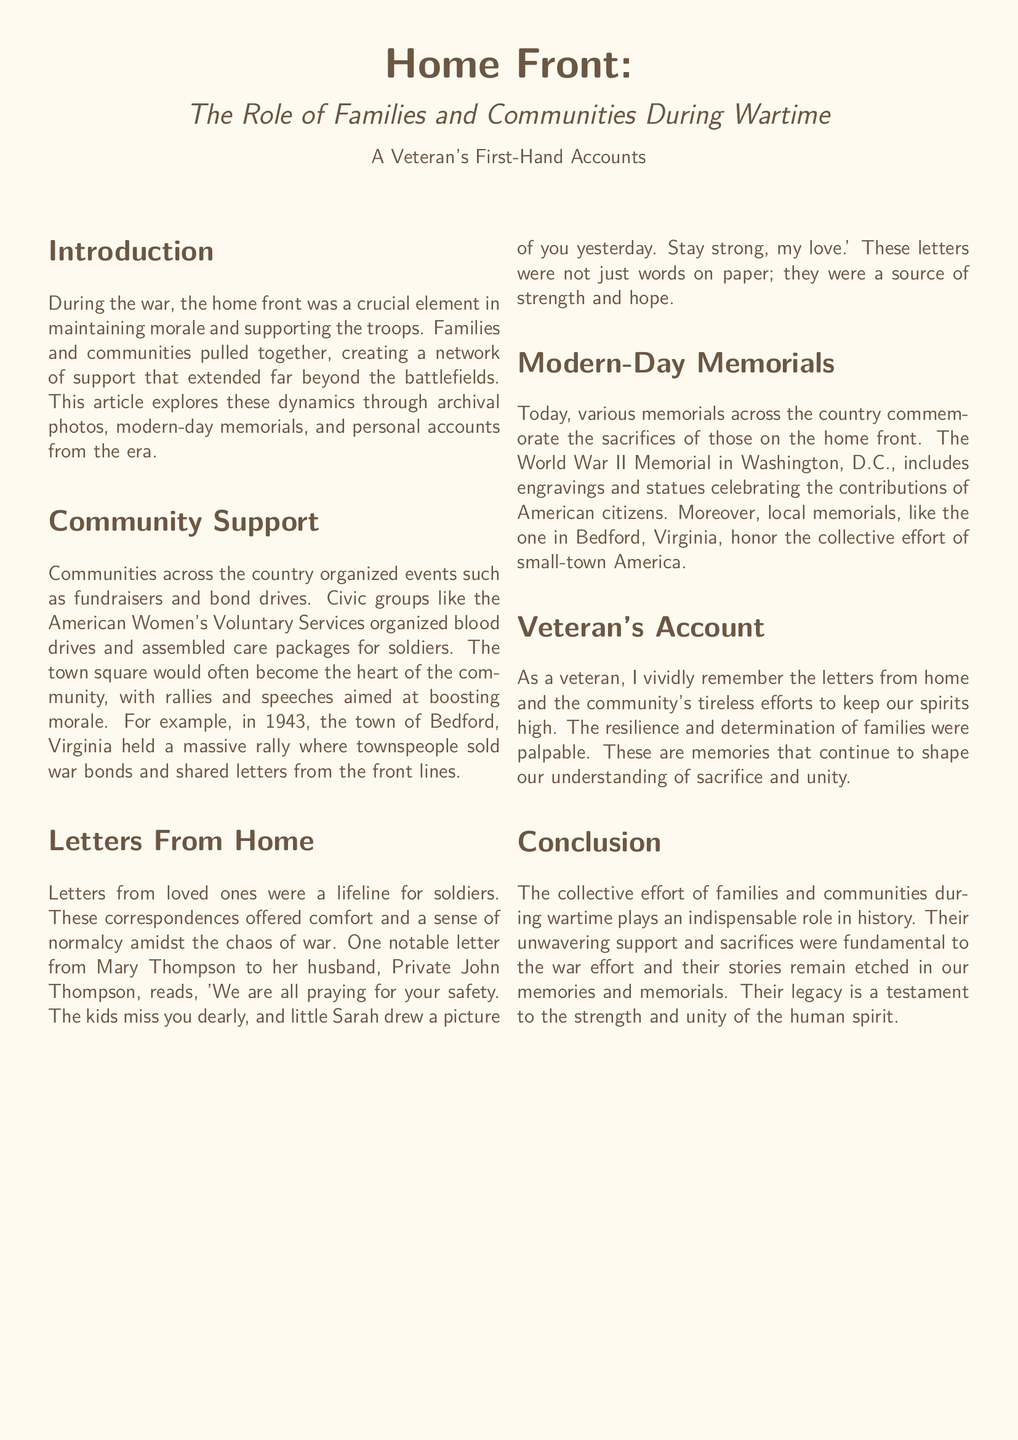What is the title of the article? The title of the article is presented at the top of the document, clearly labeled.
Answer: Home Front: The Role of Families and Communities During Wartime What year did the massive rally in Bedford, Virginia take place? The document specifies a particular year for the rally organized by the town, which is mentioned in the Community Support section.
Answer: 1943 Who wrote a notable letter to Private John Thompson? The document identifies the sender of a significant letter discussed in the Letters From Home section.
Answer: Mary Thompson What is one type of event organized by communities to support the war effort? The document lists activities that communities engaged in during wartime, mentioned in the Community Support section.
Answer: Fundraisers What major memorial in Washington, D.C. is mentioned? The document highlights a specific memorial, emphasizing its importance in commemoration.
Answer: World War II Memorial How did letters from home function for soldiers? The document describes the role of letters and their impact on soldiers, indicating their emotional significance.
Answer: Lifeline What sentiment is expressed in Mary Thompson's letter? The letter mentioned conveys feelings of love and longing, expressed through its content.
Answer: Praying for your safety In what format is the document presented? The document's layout and style are tailored for a specific presentation, providing insight into its structure.
Answer: Magazine layout 